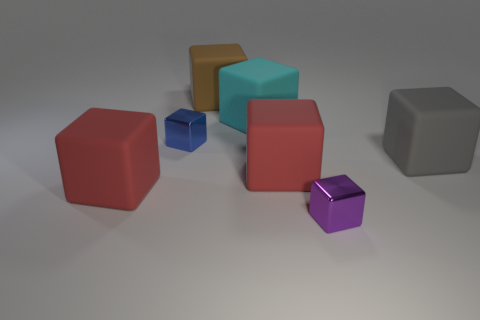What is the shape of the metallic object in front of the large red rubber thing that is on the left side of the large brown matte block?
Keep it short and to the point. Cube. The blue metallic object is what size?
Your response must be concise. Small. What shape is the purple metal object?
Your answer should be compact. Cube. There is a big brown thing; is its shape the same as the red object that is left of the cyan object?
Your answer should be very brief. Yes. How many large blocks are both right of the small blue object and in front of the big gray rubber object?
Ensure brevity in your answer.  1. How many other objects are the same size as the cyan matte thing?
Offer a terse response. 4. Are there the same number of brown rubber objects in front of the purple shiny block and purple things?
Give a very brief answer. No. Is the color of the tiny cube behind the purple object the same as the large matte thing to the left of the blue metallic cube?
Make the answer very short. No. The cube that is both behind the gray rubber cube and in front of the cyan thing is made of what material?
Your answer should be compact. Metal. What number of other things are there of the same shape as the purple metal thing?
Provide a short and direct response. 6. 